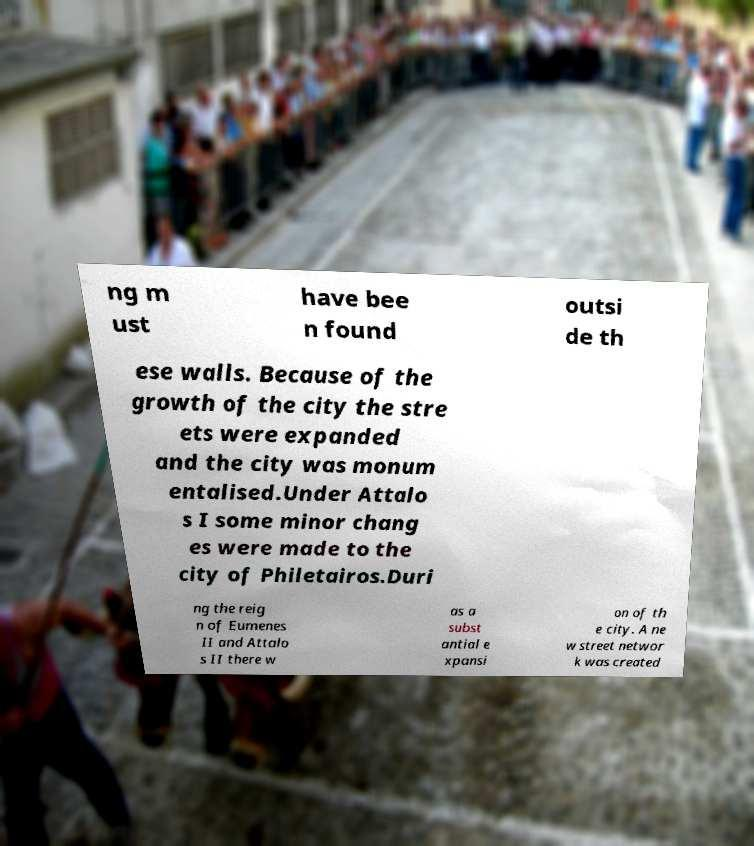There's text embedded in this image that I need extracted. Can you transcribe it verbatim? ng m ust have bee n found outsi de th ese walls. Because of the growth of the city the stre ets were expanded and the city was monum entalised.Under Attalo s I some minor chang es were made to the city of Philetairos.Duri ng the reig n of Eumenes II and Attalo s II there w as a subst antial e xpansi on of th e city. A ne w street networ k was created 